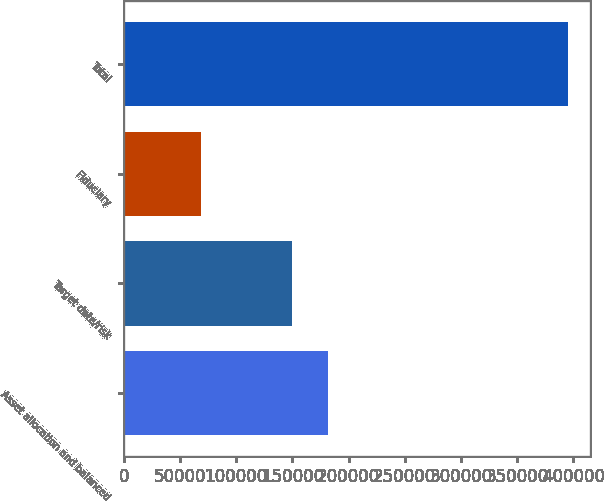Convert chart to OTSL. <chart><loc_0><loc_0><loc_500><loc_500><bar_chart><fcel>Asset allocation and balanced<fcel>Target date/risk<fcel>Fiduciary<fcel>Total<nl><fcel>182093<fcel>149432<fcel>68395<fcel>395007<nl></chart> 